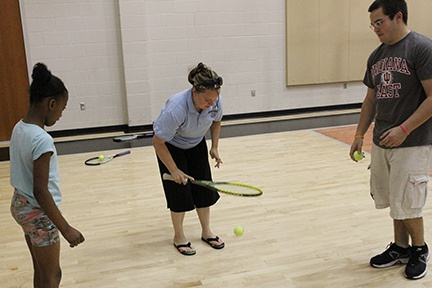Describe the objects in this image and their specific colors. I can see people in maroon, black, and gray tones, people in maroon, black, gray, and darkgray tones, people in maroon, black, gray, and brown tones, tennis racket in maroon, beige, olive, black, and gray tones, and tennis racket in maroon, darkgray, tan, black, and gray tones in this image. 